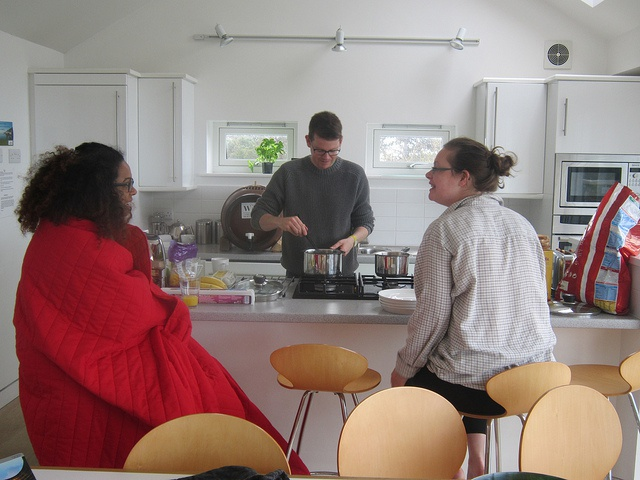Describe the objects in this image and their specific colors. I can see people in gray, brown, maroon, black, and darkgray tones, people in gray, darkgray, lightgray, and black tones, people in gray and black tones, chair in gray and tan tones, and chair in gray and tan tones in this image. 